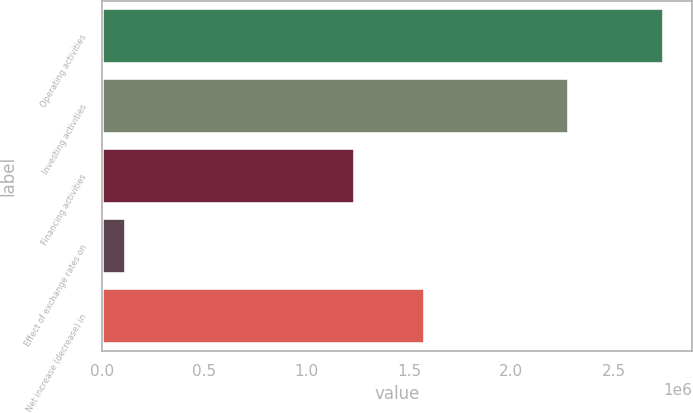Convert chart. <chart><loc_0><loc_0><loc_500><loc_500><bar_chart><fcel>Operating activities<fcel>Investing activities<fcel>Financing activities<fcel>Effect of exchange rates on<fcel>Net increase (decrease) in<nl><fcel>2.74576e+06<fcel>2.28247e+06<fcel>1.23441e+06<fcel>120103<fcel>1.57759e+06<nl></chart> 